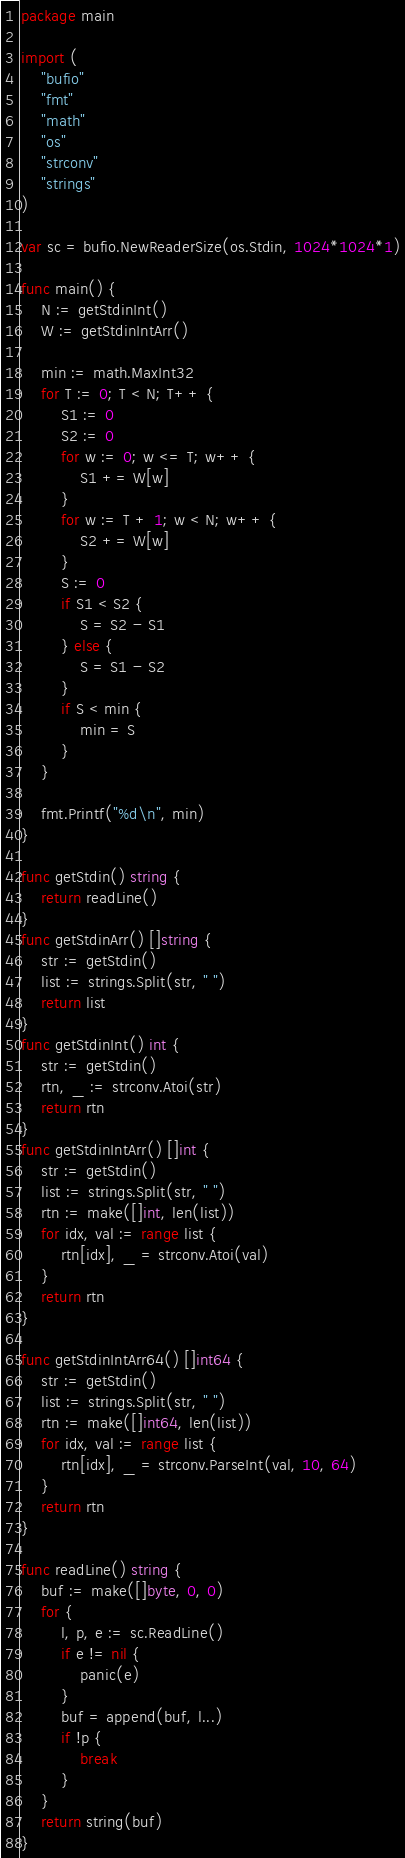Convert code to text. <code><loc_0><loc_0><loc_500><loc_500><_Go_>package main

import (
	"bufio"
	"fmt"
	"math"
	"os"
	"strconv"
	"strings"
)

var sc = bufio.NewReaderSize(os.Stdin, 1024*1024*1)

func main() {
	N := getStdinInt()
	W := getStdinIntArr()

	min := math.MaxInt32
	for T := 0; T < N; T++ {
		S1 := 0
		S2 := 0
		for w := 0; w <= T; w++ {
			S1 += W[w]
		}
		for w := T + 1; w < N; w++ {
			S2 += W[w]
		}
		S := 0
		if S1 < S2 {
			S = S2 - S1
		} else {
			S = S1 - S2
		}
		if S < min {
			min = S
		}
	}

	fmt.Printf("%d\n", min)
}

func getStdin() string {
	return readLine()
}
func getStdinArr() []string {
	str := getStdin()
	list := strings.Split(str, " ")
	return list
}
func getStdinInt() int {
	str := getStdin()
	rtn, _ := strconv.Atoi(str)
	return rtn
}
func getStdinIntArr() []int {
	str := getStdin()
	list := strings.Split(str, " ")
	rtn := make([]int, len(list))
	for idx, val := range list {
		rtn[idx], _ = strconv.Atoi(val)
	}
	return rtn
}

func getStdinIntArr64() []int64 {
	str := getStdin()
	list := strings.Split(str, " ")
	rtn := make([]int64, len(list))
	for idx, val := range list {
		rtn[idx], _ = strconv.ParseInt(val, 10, 64)
	}
	return rtn
}

func readLine() string {
	buf := make([]byte, 0, 0)
	for {
		l, p, e := sc.ReadLine()
		if e != nil {
			panic(e)
		}
		buf = append(buf, l...)
		if !p {
			break
		}
	}
	return string(buf)
}
</code> 